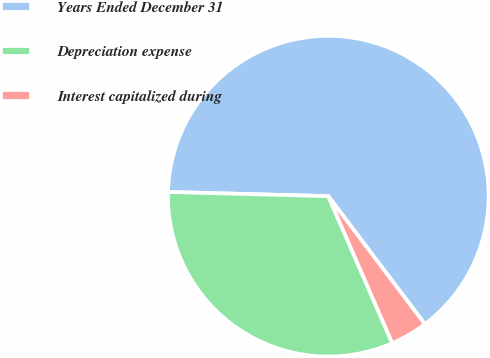Convert chart. <chart><loc_0><loc_0><loc_500><loc_500><pie_chart><fcel>Years Ended December 31<fcel>Depreciation expense<fcel>Interest capitalized during<nl><fcel>64.29%<fcel>31.95%<fcel>3.76%<nl></chart> 